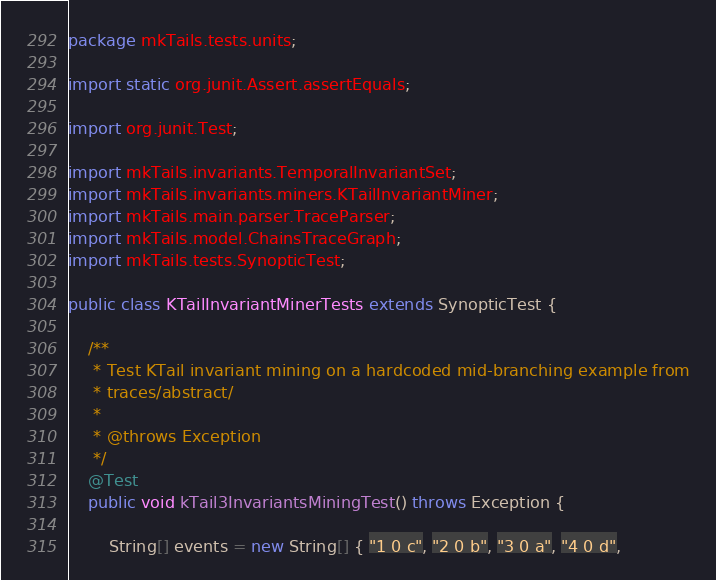Convert code to text. <code><loc_0><loc_0><loc_500><loc_500><_Java_>package mkTails.tests.units;

import static org.junit.Assert.assertEquals;

import org.junit.Test;

import mkTails.invariants.TemporalInvariantSet;
import mkTails.invariants.miners.KTailInvariantMiner;
import mkTails.main.parser.TraceParser;
import mkTails.model.ChainsTraceGraph;
import mkTails.tests.SynopticTest;

public class KTailInvariantMinerTests extends SynopticTest {

    /**
     * Test KTail invariant mining on a hardcoded mid-branching example from
     * traces/abstract/
     * 
     * @throws Exception
     */
    @Test
    public void kTail3InvariantsMiningTest() throws Exception {

        String[] events = new String[] { "1 0 c", "2 0 b", "3 0 a", "4 0 d",</code> 